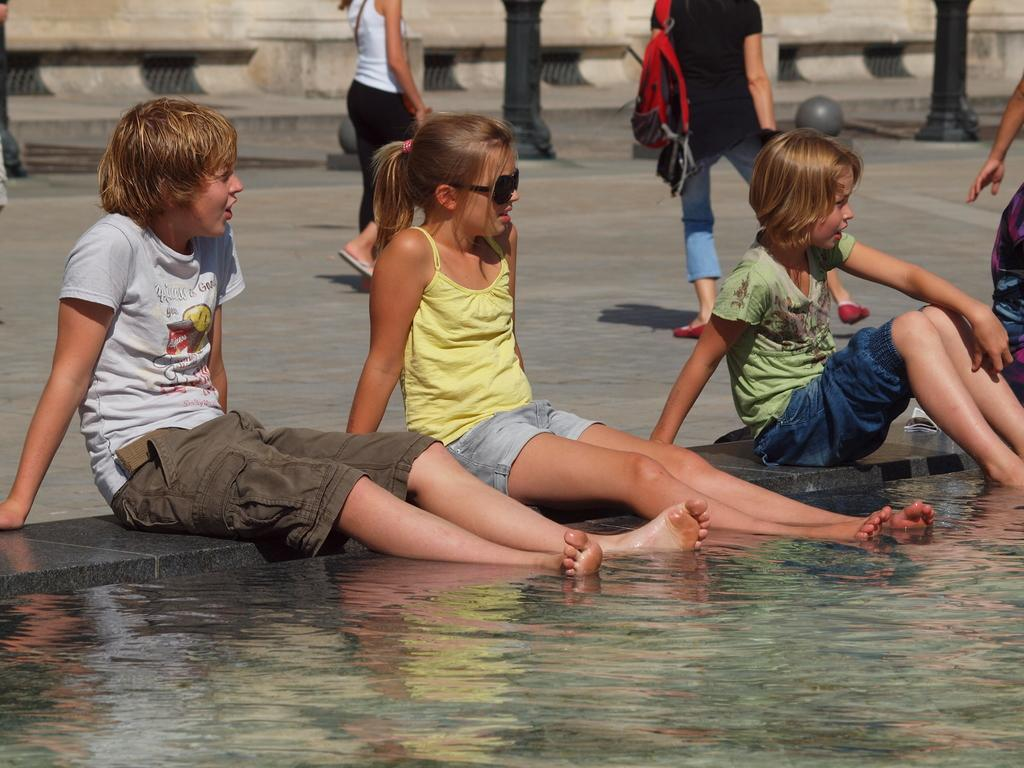What are the people in the image doing? There are people seated and walking in the image. Can you describe the appearance of the girl in the image? The girl is wearing sunglasses. What is the girl carrying in the image? A human is wearing a bag in the image. What can be seen in the background of the image? There is water visible in the image. What objects are present in the image that are not related to people? There are poles in the image. What type of brick is being used to fulfill the girl's desire in the image? There is no brick or desire present in the image; it only features people, sunglasses, a bag, water, and poles. 